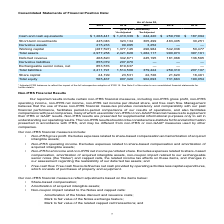According to Atlassian Plc's financial document, What do the adjusted IFRS balances reflect? The impact of the full retrospective adoption of IFRS 15. The document states: "* Adjusted IFRS balances to reflect the impact of the full retrospective adoption of IFRS 15. See Note 2 of the notes to our consolidated financial st..." Also, What are the share capital for the years as of June 30, 2015 to 2019 in chronological order? The document contains multiple relevant values: 18,461, 21,620, 22,726, 23,531, 24,199 (in thousands). From the document: "Share capital 24,199 23,531 22,726 21,620 18,461 Share capital 24,199 23,531 22,726 21,620 18,461 Share capital 24,199 23,531 22,726 21,620 18,461 Sha..." Also, What are the short-term investments for the years as of June 30, 2015 to 2019 in chronological order? The document contains multiple relevant values: 30,251, 483,405, 305,499, 323,134, 445,046 (in thousands). From the document: "Short-term investments 445,046 323,134 305,499 483,405 30,251 Short-term investments 445,046 323,134 305,499 483,405 30,251 Short-term investments 445..." Also, can you calculate: What is the difference in the value of short-term investments between fiscal years 2018 and 2019? Based on the calculation: 445,046-323,134, the result is 121912 (in thousands). This is based on the information: "Short-term investments 445,046 323,134 305,499 483,405 30,251 Short-term investments 445,046 323,134 305,499 483,405 30,251..." The key data points involved are: 323,134, 445,046. Also, can you calculate: What is the average  Total equity  for fiscal years 2015 to 2019? To answer this question, I need to perform calculations using the financial data. The calculation is: ( 565,467 + 907,320+ 902,693 + 731,663 + 190,054  )/5, which equals 659439.4 (in thousands). This is based on the information: "Total equity 565,467 907,320 902,693 731,663 190,054 Total equity 565,467 907,320 902,693 731,663 190,054 Total equity 565,467 907,320 902,693 731,663 190,054 Total equity 565,467 907,320 902,693 731,..." The key data points involved are: 190,054, 565,467, 731,663. Also, can you calculate: What is the average  Cash and cash equivalents for 2015-2019? To answer this question, I need to perform calculations using the financial data. The calculation is: (1,268,441+1,410,339+244,420+259,709+187,094)/5, which equals 674000.6 (in thousands). This is based on the information: "nts $ 1,268,441 $ 1,410,339 $ 244,420 $ 259,709 $ 187,094 h equivalents $ 1,268,441 $ 1,410,339 $ 244,420 $ 259,709 $ 187,094 Cash and cash equivalents $ 1,268,441 $ 1,410,339 $ 244,420 $ 259,709 $ 18..." The key data points involved are: 1,268,441, 1,410,339, 187,094. 